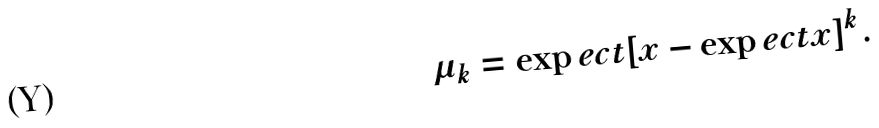<formula> <loc_0><loc_0><loc_500><loc_500>\mu _ { k } = \exp e c t { \left [ x - \exp e c t { x } \right ] ^ { k } } .</formula> 